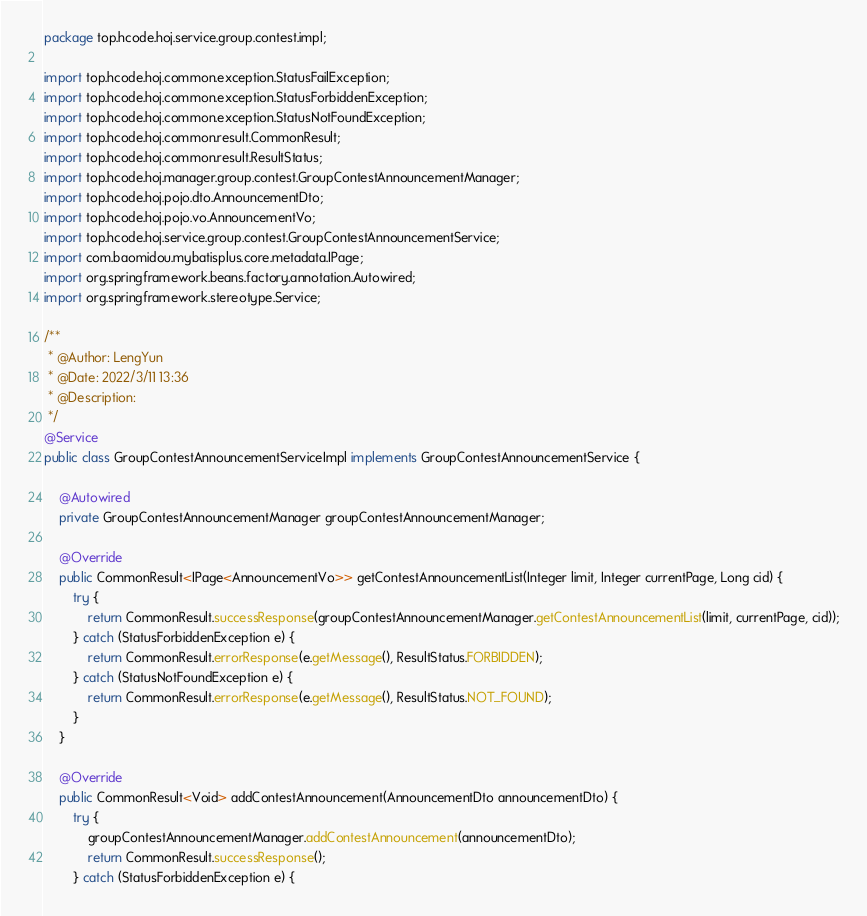<code> <loc_0><loc_0><loc_500><loc_500><_Java_>package top.hcode.hoj.service.group.contest.impl;

import top.hcode.hoj.common.exception.StatusFailException;
import top.hcode.hoj.common.exception.StatusForbiddenException;
import top.hcode.hoj.common.exception.StatusNotFoundException;
import top.hcode.hoj.common.result.CommonResult;
import top.hcode.hoj.common.result.ResultStatus;
import top.hcode.hoj.manager.group.contest.GroupContestAnnouncementManager;
import top.hcode.hoj.pojo.dto.AnnouncementDto;
import top.hcode.hoj.pojo.vo.AnnouncementVo;
import top.hcode.hoj.service.group.contest.GroupContestAnnouncementService;
import com.baomidou.mybatisplus.core.metadata.IPage;
import org.springframework.beans.factory.annotation.Autowired;
import org.springframework.stereotype.Service;

/**
 * @Author: LengYun
 * @Date: 2022/3/11 13:36
 * @Description:
 */
@Service
public class GroupContestAnnouncementServiceImpl implements GroupContestAnnouncementService {

    @Autowired
    private GroupContestAnnouncementManager groupContestAnnouncementManager;

    @Override
    public CommonResult<IPage<AnnouncementVo>> getContestAnnouncementList(Integer limit, Integer currentPage, Long cid) {
        try {
            return CommonResult.successResponse(groupContestAnnouncementManager.getContestAnnouncementList(limit, currentPage, cid));
        } catch (StatusForbiddenException e) {
            return CommonResult.errorResponse(e.getMessage(), ResultStatus.FORBIDDEN);
        } catch (StatusNotFoundException e) {
            return CommonResult.errorResponse(e.getMessage(), ResultStatus.NOT_FOUND);
        }
    }

    @Override
    public CommonResult<Void> addContestAnnouncement(AnnouncementDto announcementDto) {
        try {
            groupContestAnnouncementManager.addContestAnnouncement(announcementDto);
            return CommonResult.successResponse();
        } catch (StatusForbiddenException e) {</code> 